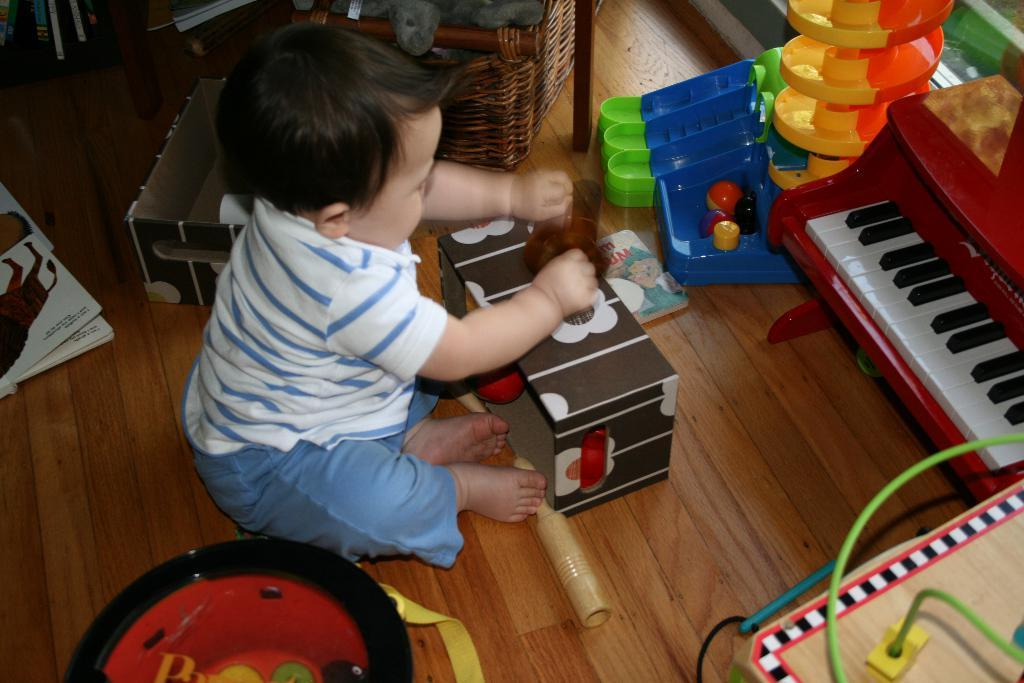What is the main subject of the image? The main subject of the image is a kid. What is the kid doing in the image? The kid is playing with toys in the image. Where are the toys located in the image? The toys are on the floor in the image. What can be found beside the kid in the image? There is a basket beside the kid in the image. What is inside the basket? The basket contains a teddy bear. What type of writing can be seen on the toys in the image? There is no writing visible on the toys in the image. How many geese are present in the image? There are no geese present in the image. 